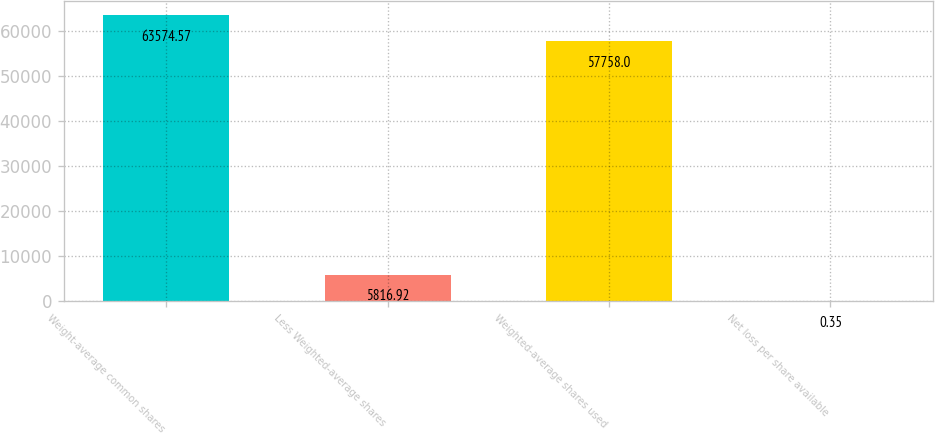Convert chart to OTSL. <chart><loc_0><loc_0><loc_500><loc_500><bar_chart><fcel>Weight-average common shares<fcel>Less Weighted-average shares<fcel>Weighted-average shares used<fcel>Net loss per share available<nl><fcel>63574.6<fcel>5816.92<fcel>57758<fcel>0.35<nl></chart> 